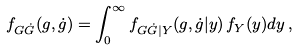<formula> <loc_0><loc_0><loc_500><loc_500>f _ { G \dot { G } } ( g , \dot { g } ) = \int _ { 0 } ^ { \infty } f _ { G \dot { G } | Y } ( g , \dot { g } | y ) \, f _ { Y } ( y ) d y \, ,</formula> 